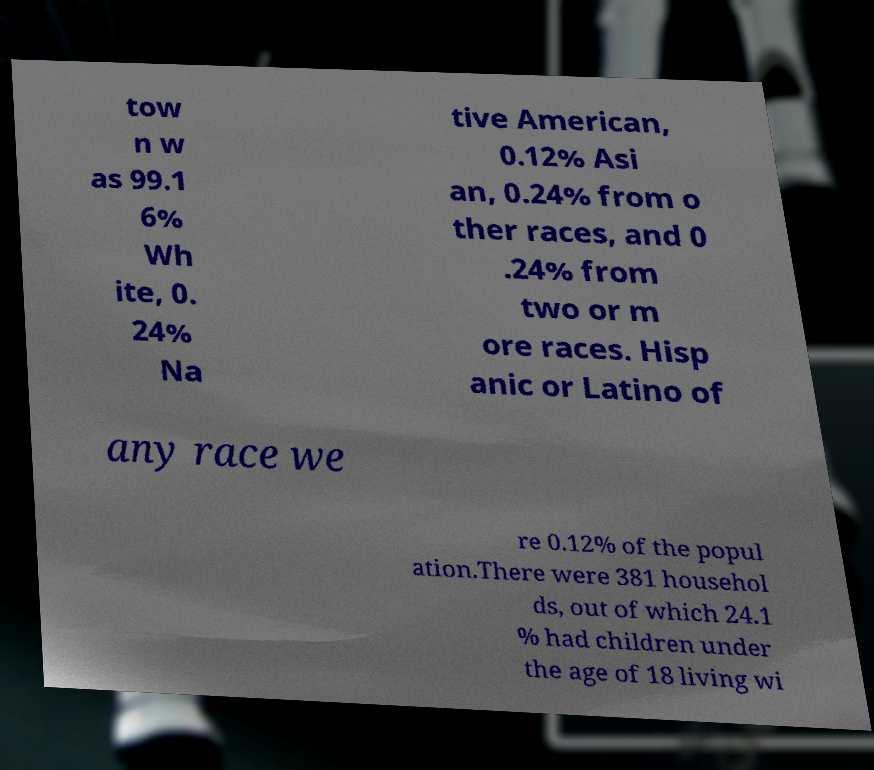For documentation purposes, I need the text within this image transcribed. Could you provide that? tow n w as 99.1 6% Wh ite, 0. 24% Na tive American, 0.12% Asi an, 0.24% from o ther races, and 0 .24% from two or m ore races. Hisp anic or Latino of any race we re 0.12% of the popul ation.There were 381 househol ds, out of which 24.1 % had children under the age of 18 living wi 